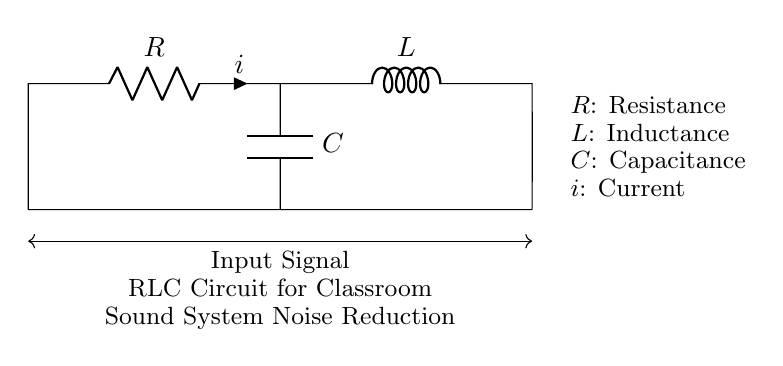What components are present in this circuit? The circuit includes a resistor, an inductor, and a capacitor, which are indicated by the labels R, L, and C.
Answer: resistor, inductor, capacitor What is the purpose of the capacitor in this RLC circuit? The capacitor helps filter high-frequency noise from the input signal, allowing the desired frequencies to pass through more effectively, thus reducing unwanted noise.
Answer: filter noise What is the current direction indicated by the diagram? The current direction is represented by the arrow labeled i, which shows the flow from left to right through the circuit components.
Answer: left to right Which component is responsible for energy storage in this circuit? The inductor is responsible for storing energy in the form of a magnetic field when current flows through it, while the capacitor stores energy in an electric field.
Answer: inductor How does increasing the resistance affect the performance of this circuit? Increasing the resistance reduces the overall current flowing through the circuit, which can decrease the voltage across the capacitor and affect the circuit's ability to filter out unwanted noise effectively.
Answer: decreases current What type of filter action does this RLC circuit perform? This RLC circuit performs a low-pass filter action, allowing low-frequency signals to pass while attenuating high-frequency noise.
Answer: low-pass filter 